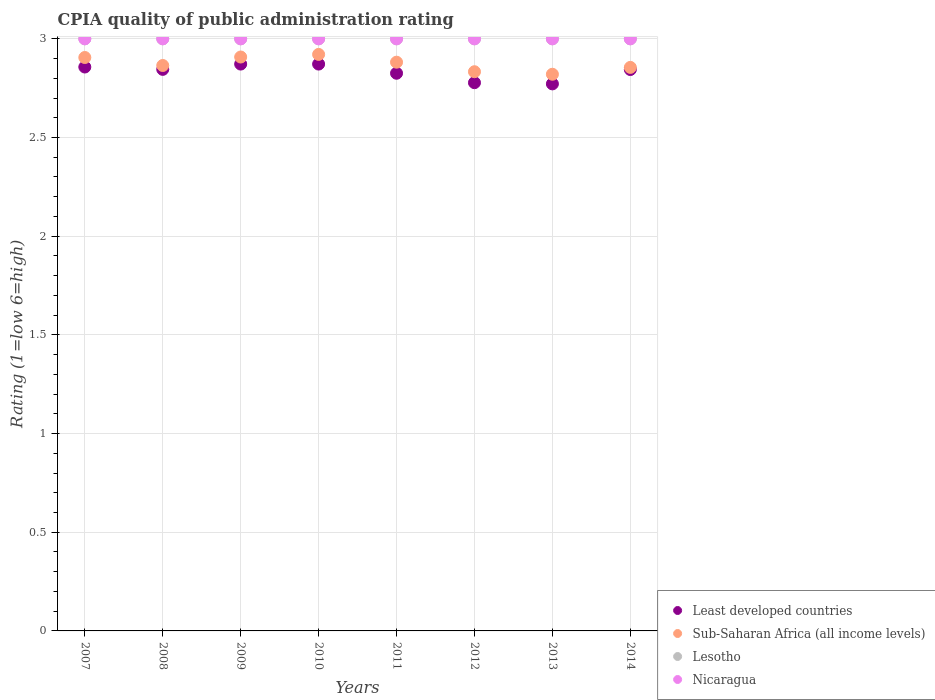Is the number of dotlines equal to the number of legend labels?
Keep it short and to the point. Yes. What is the CPIA rating in Sub-Saharan Africa (all income levels) in 2009?
Keep it short and to the point. 2.91. Across all years, what is the maximum CPIA rating in Nicaragua?
Provide a succinct answer. 3. Across all years, what is the minimum CPIA rating in Lesotho?
Make the answer very short. 3. In which year was the CPIA rating in Lesotho maximum?
Ensure brevity in your answer.  2007. In which year was the CPIA rating in Sub-Saharan Africa (all income levels) minimum?
Provide a short and direct response. 2013. What is the total CPIA rating in Lesotho in the graph?
Your answer should be very brief. 24. What is the difference between the CPIA rating in Sub-Saharan Africa (all income levels) in 2013 and the CPIA rating in Lesotho in 2008?
Give a very brief answer. -0.18. What is the average CPIA rating in Sub-Saharan Africa (all income levels) per year?
Provide a succinct answer. 2.87. In the year 2012, what is the difference between the CPIA rating in Sub-Saharan Africa (all income levels) and CPIA rating in Lesotho?
Offer a terse response. -0.17. In how many years, is the CPIA rating in Least developed countries greater than 1.4?
Make the answer very short. 8. What is the difference between the highest and the second highest CPIA rating in Lesotho?
Offer a terse response. 0. Is the sum of the CPIA rating in Sub-Saharan Africa (all income levels) in 2007 and 2012 greater than the maximum CPIA rating in Least developed countries across all years?
Offer a terse response. Yes. Is it the case that in every year, the sum of the CPIA rating in Lesotho and CPIA rating in Nicaragua  is greater than the sum of CPIA rating in Least developed countries and CPIA rating in Sub-Saharan Africa (all income levels)?
Keep it short and to the point. No. Is the CPIA rating in Nicaragua strictly greater than the CPIA rating in Lesotho over the years?
Your response must be concise. No. Is the CPIA rating in Sub-Saharan Africa (all income levels) strictly less than the CPIA rating in Nicaragua over the years?
Make the answer very short. Yes. How many dotlines are there?
Make the answer very short. 4. How many years are there in the graph?
Your answer should be very brief. 8. Does the graph contain any zero values?
Provide a succinct answer. No. Does the graph contain grids?
Keep it short and to the point. Yes. Where does the legend appear in the graph?
Your answer should be very brief. Bottom right. How many legend labels are there?
Provide a short and direct response. 4. How are the legend labels stacked?
Make the answer very short. Vertical. What is the title of the graph?
Keep it short and to the point. CPIA quality of public administration rating. What is the label or title of the X-axis?
Offer a very short reply. Years. What is the label or title of the Y-axis?
Give a very brief answer. Rating (1=low 6=high). What is the Rating (1=low 6=high) in Least developed countries in 2007?
Offer a very short reply. 2.86. What is the Rating (1=low 6=high) in Sub-Saharan Africa (all income levels) in 2007?
Offer a terse response. 2.91. What is the Rating (1=low 6=high) in Nicaragua in 2007?
Give a very brief answer. 3. What is the Rating (1=low 6=high) of Least developed countries in 2008?
Offer a very short reply. 2.85. What is the Rating (1=low 6=high) in Sub-Saharan Africa (all income levels) in 2008?
Ensure brevity in your answer.  2.86. What is the Rating (1=low 6=high) in Least developed countries in 2009?
Your response must be concise. 2.87. What is the Rating (1=low 6=high) of Sub-Saharan Africa (all income levels) in 2009?
Offer a terse response. 2.91. What is the Rating (1=low 6=high) in Lesotho in 2009?
Give a very brief answer. 3. What is the Rating (1=low 6=high) in Least developed countries in 2010?
Make the answer very short. 2.87. What is the Rating (1=low 6=high) in Sub-Saharan Africa (all income levels) in 2010?
Provide a short and direct response. 2.92. What is the Rating (1=low 6=high) in Lesotho in 2010?
Provide a succinct answer. 3. What is the Rating (1=low 6=high) of Nicaragua in 2010?
Make the answer very short. 3. What is the Rating (1=low 6=high) in Least developed countries in 2011?
Make the answer very short. 2.83. What is the Rating (1=low 6=high) of Sub-Saharan Africa (all income levels) in 2011?
Your response must be concise. 2.88. What is the Rating (1=low 6=high) of Least developed countries in 2012?
Your response must be concise. 2.78. What is the Rating (1=low 6=high) of Sub-Saharan Africa (all income levels) in 2012?
Your response must be concise. 2.83. What is the Rating (1=low 6=high) of Lesotho in 2012?
Give a very brief answer. 3. What is the Rating (1=low 6=high) in Nicaragua in 2012?
Give a very brief answer. 3. What is the Rating (1=low 6=high) of Least developed countries in 2013?
Provide a short and direct response. 2.77. What is the Rating (1=low 6=high) in Sub-Saharan Africa (all income levels) in 2013?
Keep it short and to the point. 2.82. What is the Rating (1=low 6=high) in Nicaragua in 2013?
Your answer should be very brief. 3. What is the Rating (1=low 6=high) in Least developed countries in 2014?
Provide a succinct answer. 2.84. What is the Rating (1=low 6=high) in Sub-Saharan Africa (all income levels) in 2014?
Your response must be concise. 2.86. What is the Rating (1=low 6=high) in Lesotho in 2014?
Your answer should be very brief. 3. Across all years, what is the maximum Rating (1=low 6=high) in Least developed countries?
Provide a short and direct response. 2.87. Across all years, what is the maximum Rating (1=low 6=high) of Sub-Saharan Africa (all income levels)?
Your answer should be compact. 2.92. Across all years, what is the maximum Rating (1=low 6=high) in Lesotho?
Keep it short and to the point. 3. Across all years, what is the minimum Rating (1=low 6=high) of Least developed countries?
Keep it short and to the point. 2.77. Across all years, what is the minimum Rating (1=low 6=high) of Sub-Saharan Africa (all income levels)?
Your answer should be compact. 2.82. Across all years, what is the minimum Rating (1=low 6=high) of Lesotho?
Offer a terse response. 3. What is the total Rating (1=low 6=high) in Least developed countries in the graph?
Give a very brief answer. 22.67. What is the total Rating (1=low 6=high) in Sub-Saharan Africa (all income levels) in the graph?
Provide a short and direct response. 22.99. What is the total Rating (1=low 6=high) of Lesotho in the graph?
Make the answer very short. 24. What is the difference between the Rating (1=low 6=high) of Least developed countries in 2007 and that in 2008?
Make the answer very short. 0.01. What is the difference between the Rating (1=low 6=high) of Sub-Saharan Africa (all income levels) in 2007 and that in 2008?
Your response must be concise. 0.04. What is the difference between the Rating (1=low 6=high) in Nicaragua in 2007 and that in 2008?
Offer a very short reply. 0. What is the difference between the Rating (1=low 6=high) of Least developed countries in 2007 and that in 2009?
Offer a very short reply. -0.01. What is the difference between the Rating (1=low 6=high) in Sub-Saharan Africa (all income levels) in 2007 and that in 2009?
Your answer should be very brief. -0. What is the difference between the Rating (1=low 6=high) in Nicaragua in 2007 and that in 2009?
Your answer should be very brief. 0. What is the difference between the Rating (1=low 6=high) in Least developed countries in 2007 and that in 2010?
Offer a very short reply. -0.01. What is the difference between the Rating (1=low 6=high) in Sub-Saharan Africa (all income levels) in 2007 and that in 2010?
Ensure brevity in your answer.  -0.02. What is the difference between the Rating (1=low 6=high) of Least developed countries in 2007 and that in 2011?
Offer a very short reply. 0.03. What is the difference between the Rating (1=low 6=high) in Sub-Saharan Africa (all income levels) in 2007 and that in 2011?
Your answer should be compact. 0.02. What is the difference between the Rating (1=low 6=high) of Nicaragua in 2007 and that in 2011?
Provide a succinct answer. 0. What is the difference between the Rating (1=low 6=high) of Least developed countries in 2007 and that in 2012?
Keep it short and to the point. 0.08. What is the difference between the Rating (1=low 6=high) in Sub-Saharan Africa (all income levels) in 2007 and that in 2012?
Make the answer very short. 0.07. What is the difference between the Rating (1=low 6=high) of Lesotho in 2007 and that in 2012?
Offer a very short reply. 0. What is the difference between the Rating (1=low 6=high) of Nicaragua in 2007 and that in 2012?
Your answer should be very brief. 0. What is the difference between the Rating (1=low 6=high) in Least developed countries in 2007 and that in 2013?
Ensure brevity in your answer.  0.09. What is the difference between the Rating (1=low 6=high) in Sub-Saharan Africa (all income levels) in 2007 and that in 2013?
Offer a terse response. 0.08. What is the difference between the Rating (1=low 6=high) of Lesotho in 2007 and that in 2013?
Provide a short and direct response. 0. What is the difference between the Rating (1=low 6=high) of Nicaragua in 2007 and that in 2013?
Offer a terse response. 0. What is the difference between the Rating (1=low 6=high) of Least developed countries in 2007 and that in 2014?
Offer a terse response. 0.01. What is the difference between the Rating (1=low 6=high) in Sub-Saharan Africa (all income levels) in 2007 and that in 2014?
Your response must be concise. 0.05. What is the difference between the Rating (1=low 6=high) of Nicaragua in 2007 and that in 2014?
Provide a succinct answer. 0. What is the difference between the Rating (1=low 6=high) in Least developed countries in 2008 and that in 2009?
Your response must be concise. -0.03. What is the difference between the Rating (1=low 6=high) of Sub-Saharan Africa (all income levels) in 2008 and that in 2009?
Give a very brief answer. -0.04. What is the difference between the Rating (1=low 6=high) in Least developed countries in 2008 and that in 2010?
Make the answer very short. -0.03. What is the difference between the Rating (1=low 6=high) of Sub-Saharan Africa (all income levels) in 2008 and that in 2010?
Keep it short and to the point. -0.06. What is the difference between the Rating (1=low 6=high) of Lesotho in 2008 and that in 2010?
Make the answer very short. 0. What is the difference between the Rating (1=low 6=high) of Nicaragua in 2008 and that in 2010?
Make the answer very short. 0. What is the difference between the Rating (1=low 6=high) in Least developed countries in 2008 and that in 2011?
Provide a short and direct response. 0.02. What is the difference between the Rating (1=low 6=high) in Sub-Saharan Africa (all income levels) in 2008 and that in 2011?
Provide a short and direct response. -0.02. What is the difference between the Rating (1=low 6=high) of Nicaragua in 2008 and that in 2011?
Offer a very short reply. 0. What is the difference between the Rating (1=low 6=high) of Least developed countries in 2008 and that in 2012?
Your answer should be compact. 0.07. What is the difference between the Rating (1=low 6=high) in Sub-Saharan Africa (all income levels) in 2008 and that in 2012?
Your answer should be very brief. 0.03. What is the difference between the Rating (1=low 6=high) of Lesotho in 2008 and that in 2012?
Provide a succinct answer. 0. What is the difference between the Rating (1=low 6=high) in Nicaragua in 2008 and that in 2012?
Provide a short and direct response. 0. What is the difference between the Rating (1=low 6=high) in Least developed countries in 2008 and that in 2013?
Your response must be concise. 0.07. What is the difference between the Rating (1=low 6=high) of Sub-Saharan Africa (all income levels) in 2008 and that in 2013?
Give a very brief answer. 0.04. What is the difference between the Rating (1=low 6=high) of Nicaragua in 2008 and that in 2013?
Your answer should be compact. 0. What is the difference between the Rating (1=low 6=high) of Least developed countries in 2008 and that in 2014?
Your answer should be very brief. 0. What is the difference between the Rating (1=low 6=high) in Sub-Saharan Africa (all income levels) in 2008 and that in 2014?
Offer a terse response. 0.01. What is the difference between the Rating (1=low 6=high) of Least developed countries in 2009 and that in 2010?
Offer a very short reply. 0. What is the difference between the Rating (1=low 6=high) of Sub-Saharan Africa (all income levels) in 2009 and that in 2010?
Ensure brevity in your answer.  -0.01. What is the difference between the Rating (1=low 6=high) in Lesotho in 2009 and that in 2010?
Offer a very short reply. 0. What is the difference between the Rating (1=low 6=high) of Nicaragua in 2009 and that in 2010?
Offer a very short reply. 0. What is the difference between the Rating (1=low 6=high) of Least developed countries in 2009 and that in 2011?
Provide a short and direct response. 0.05. What is the difference between the Rating (1=low 6=high) in Sub-Saharan Africa (all income levels) in 2009 and that in 2011?
Provide a short and direct response. 0.03. What is the difference between the Rating (1=low 6=high) of Least developed countries in 2009 and that in 2012?
Offer a very short reply. 0.09. What is the difference between the Rating (1=low 6=high) of Sub-Saharan Africa (all income levels) in 2009 and that in 2012?
Provide a short and direct response. 0.07. What is the difference between the Rating (1=low 6=high) of Least developed countries in 2009 and that in 2013?
Your response must be concise. 0.1. What is the difference between the Rating (1=low 6=high) of Sub-Saharan Africa (all income levels) in 2009 and that in 2013?
Provide a short and direct response. 0.09. What is the difference between the Rating (1=low 6=high) in Nicaragua in 2009 and that in 2013?
Offer a very short reply. 0. What is the difference between the Rating (1=low 6=high) of Least developed countries in 2009 and that in 2014?
Your answer should be very brief. 0.03. What is the difference between the Rating (1=low 6=high) of Sub-Saharan Africa (all income levels) in 2009 and that in 2014?
Ensure brevity in your answer.  0.05. What is the difference between the Rating (1=low 6=high) of Lesotho in 2009 and that in 2014?
Provide a short and direct response. 0. What is the difference between the Rating (1=low 6=high) of Nicaragua in 2009 and that in 2014?
Make the answer very short. 0. What is the difference between the Rating (1=low 6=high) of Least developed countries in 2010 and that in 2011?
Your answer should be compact. 0.05. What is the difference between the Rating (1=low 6=high) in Sub-Saharan Africa (all income levels) in 2010 and that in 2011?
Give a very brief answer. 0.04. What is the difference between the Rating (1=low 6=high) in Lesotho in 2010 and that in 2011?
Give a very brief answer. 0. What is the difference between the Rating (1=low 6=high) of Nicaragua in 2010 and that in 2011?
Offer a very short reply. 0. What is the difference between the Rating (1=low 6=high) in Least developed countries in 2010 and that in 2012?
Your response must be concise. 0.09. What is the difference between the Rating (1=low 6=high) of Sub-Saharan Africa (all income levels) in 2010 and that in 2012?
Give a very brief answer. 0.09. What is the difference between the Rating (1=low 6=high) in Nicaragua in 2010 and that in 2012?
Your answer should be very brief. 0. What is the difference between the Rating (1=low 6=high) in Least developed countries in 2010 and that in 2013?
Your answer should be compact. 0.1. What is the difference between the Rating (1=low 6=high) in Sub-Saharan Africa (all income levels) in 2010 and that in 2013?
Your answer should be compact. 0.1. What is the difference between the Rating (1=low 6=high) in Least developed countries in 2010 and that in 2014?
Give a very brief answer. 0.03. What is the difference between the Rating (1=low 6=high) in Sub-Saharan Africa (all income levels) in 2010 and that in 2014?
Ensure brevity in your answer.  0.07. What is the difference between the Rating (1=low 6=high) of Nicaragua in 2010 and that in 2014?
Offer a very short reply. 0. What is the difference between the Rating (1=low 6=high) of Least developed countries in 2011 and that in 2012?
Your answer should be compact. 0.05. What is the difference between the Rating (1=low 6=high) of Sub-Saharan Africa (all income levels) in 2011 and that in 2012?
Offer a terse response. 0.05. What is the difference between the Rating (1=low 6=high) in Nicaragua in 2011 and that in 2012?
Your answer should be compact. 0. What is the difference between the Rating (1=low 6=high) in Least developed countries in 2011 and that in 2013?
Provide a succinct answer. 0.05. What is the difference between the Rating (1=low 6=high) of Sub-Saharan Africa (all income levels) in 2011 and that in 2013?
Make the answer very short. 0.06. What is the difference between the Rating (1=low 6=high) in Nicaragua in 2011 and that in 2013?
Keep it short and to the point. 0. What is the difference between the Rating (1=low 6=high) of Least developed countries in 2011 and that in 2014?
Keep it short and to the point. -0.02. What is the difference between the Rating (1=low 6=high) of Sub-Saharan Africa (all income levels) in 2011 and that in 2014?
Keep it short and to the point. 0.03. What is the difference between the Rating (1=low 6=high) of Lesotho in 2011 and that in 2014?
Offer a very short reply. 0. What is the difference between the Rating (1=low 6=high) in Nicaragua in 2011 and that in 2014?
Your answer should be very brief. 0. What is the difference between the Rating (1=low 6=high) in Least developed countries in 2012 and that in 2013?
Ensure brevity in your answer.  0.01. What is the difference between the Rating (1=low 6=high) in Sub-Saharan Africa (all income levels) in 2012 and that in 2013?
Keep it short and to the point. 0.01. What is the difference between the Rating (1=low 6=high) in Lesotho in 2012 and that in 2013?
Offer a terse response. 0. What is the difference between the Rating (1=low 6=high) in Least developed countries in 2012 and that in 2014?
Your answer should be compact. -0.07. What is the difference between the Rating (1=low 6=high) of Sub-Saharan Africa (all income levels) in 2012 and that in 2014?
Your answer should be compact. -0.02. What is the difference between the Rating (1=low 6=high) of Lesotho in 2012 and that in 2014?
Your answer should be very brief. 0. What is the difference between the Rating (1=low 6=high) in Least developed countries in 2013 and that in 2014?
Your answer should be very brief. -0.07. What is the difference between the Rating (1=low 6=high) of Sub-Saharan Africa (all income levels) in 2013 and that in 2014?
Give a very brief answer. -0.03. What is the difference between the Rating (1=low 6=high) of Nicaragua in 2013 and that in 2014?
Your answer should be compact. 0. What is the difference between the Rating (1=low 6=high) of Least developed countries in 2007 and the Rating (1=low 6=high) of Sub-Saharan Africa (all income levels) in 2008?
Offer a terse response. -0.01. What is the difference between the Rating (1=low 6=high) in Least developed countries in 2007 and the Rating (1=low 6=high) in Lesotho in 2008?
Make the answer very short. -0.14. What is the difference between the Rating (1=low 6=high) of Least developed countries in 2007 and the Rating (1=low 6=high) of Nicaragua in 2008?
Keep it short and to the point. -0.14. What is the difference between the Rating (1=low 6=high) in Sub-Saharan Africa (all income levels) in 2007 and the Rating (1=low 6=high) in Lesotho in 2008?
Provide a succinct answer. -0.09. What is the difference between the Rating (1=low 6=high) of Sub-Saharan Africa (all income levels) in 2007 and the Rating (1=low 6=high) of Nicaragua in 2008?
Your answer should be very brief. -0.09. What is the difference between the Rating (1=low 6=high) in Least developed countries in 2007 and the Rating (1=low 6=high) in Sub-Saharan Africa (all income levels) in 2009?
Ensure brevity in your answer.  -0.05. What is the difference between the Rating (1=low 6=high) of Least developed countries in 2007 and the Rating (1=low 6=high) of Lesotho in 2009?
Give a very brief answer. -0.14. What is the difference between the Rating (1=low 6=high) in Least developed countries in 2007 and the Rating (1=low 6=high) in Nicaragua in 2009?
Offer a very short reply. -0.14. What is the difference between the Rating (1=low 6=high) in Sub-Saharan Africa (all income levels) in 2007 and the Rating (1=low 6=high) in Lesotho in 2009?
Your response must be concise. -0.09. What is the difference between the Rating (1=low 6=high) of Sub-Saharan Africa (all income levels) in 2007 and the Rating (1=low 6=high) of Nicaragua in 2009?
Provide a short and direct response. -0.09. What is the difference between the Rating (1=low 6=high) of Lesotho in 2007 and the Rating (1=low 6=high) of Nicaragua in 2009?
Offer a very short reply. 0. What is the difference between the Rating (1=low 6=high) in Least developed countries in 2007 and the Rating (1=low 6=high) in Sub-Saharan Africa (all income levels) in 2010?
Offer a very short reply. -0.06. What is the difference between the Rating (1=low 6=high) of Least developed countries in 2007 and the Rating (1=low 6=high) of Lesotho in 2010?
Keep it short and to the point. -0.14. What is the difference between the Rating (1=low 6=high) of Least developed countries in 2007 and the Rating (1=low 6=high) of Nicaragua in 2010?
Make the answer very short. -0.14. What is the difference between the Rating (1=low 6=high) in Sub-Saharan Africa (all income levels) in 2007 and the Rating (1=low 6=high) in Lesotho in 2010?
Make the answer very short. -0.09. What is the difference between the Rating (1=low 6=high) of Sub-Saharan Africa (all income levels) in 2007 and the Rating (1=low 6=high) of Nicaragua in 2010?
Keep it short and to the point. -0.09. What is the difference between the Rating (1=low 6=high) of Least developed countries in 2007 and the Rating (1=low 6=high) of Sub-Saharan Africa (all income levels) in 2011?
Offer a very short reply. -0.02. What is the difference between the Rating (1=low 6=high) in Least developed countries in 2007 and the Rating (1=low 6=high) in Lesotho in 2011?
Provide a short and direct response. -0.14. What is the difference between the Rating (1=low 6=high) in Least developed countries in 2007 and the Rating (1=low 6=high) in Nicaragua in 2011?
Your response must be concise. -0.14. What is the difference between the Rating (1=low 6=high) in Sub-Saharan Africa (all income levels) in 2007 and the Rating (1=low 6=high) in Lesotho in 2011?
Make the answer very short. -0.09. What is the difference between the Rating (1=low 6=high) in Sub-Saharan Africa (all income levels) in 2007 and the Rating (1=low 6=high) in Nicaragua in 2011?
Your response must be concise. -0.09. What is the difference between the Rating (1=low 6=high) of Lesotho in 2007 and the Rating (1=low 6=high) of Nicaragua in 2011?
Keep it short and to the point. 0. What is the difference between the Rating (1=low 6=high) of Least developed countries in 2007 and the Rating (1=low 6=high) of Sub-Saharan Africa (all income levels) in 2012?
Your answer should be compact. 0.02. What is the difference between the Rating (1=low 6=high) in Least developed countries in 2007 and the Rating (1=low 6=high) in Lesotho in 2012?
Give a very brief answer. -0.14. What is the difference between the Rating (1=low 6=high) of Least developed countries in 2007 and the Rating (1=low 6=high) of Nicaragua in 2012?
Give a very brief answer. -0.14. What is the difference between the Rating (1=low 6=high) of Sub-Saharan Africa (all income levels) in 2007 and the Rating (1=low 6=high) of Lesotho in 2012?
Offer a terse response. -0.09. What is the difference between the Rating (1=low 6=high) of Sub-Saharan Africa (all income levels) in 2007 and the Rating (1=low 6=high) of Nicaragua in 2012?
Make the answer very short. -0.09. What is the difference between the Rating (1=low 6=high) in Lesotho in 2007 and the Rating (1=low 6=high) in Nicaragua in 2012?
Provide a short and direct response. 0. What is the difference between the Rating (1=low 6=high) of Least developed countries in 2007 and the Rating (1=low 6=high) of Sub-Saharan Africa (all income levels) in 2013?
Make the answer very short. 0.04. What is the difference between the Rating (1=low 6=high) in Least developed countries in 2007 and the Rating (1=low 6=high) in Lesotho in 2013?
Your answer should be compact. -0.14. What is the difference between the Rating (1=low 6=high) in Least developed countries in 2007 and the Rating (1=low 6=high) in Nicaragua in 2013?
Ensure brevity in your answer.  -0.14. What is the difference between the Rating (1=low 6=high) in Sub-Saharan Africa (all income levels) in 2007 and the Rating (1=low 6=high) in Lesotho in 2013?
Provide a succinct answer. -0.09. What is the difference between the Rating (1=low 6=high) in Sub-Saharan Africa (all income levels) in 2007 and the Rating (1=low 6=high) in Nicaragua in 2013?
Offer a very short reply. -0.09. What is the difference between the Rating (1=low 6=high) of Lesotho in 2007 and the Rating (1=low 6=high) of Nicaragua in 2013?
Ensure brevity in your answer.  0. What is the difference between the Rating (1=low 6=high) in Least developed countries in 2007 and the Rating (1=low 6=high) in Sub-Saharan Africa (all income levels) in 2014?
Offer a very short reply. 0. What is the difference between the Rating (1=low 6=high) in Least developed countries in 2007 and the Rating (1=low 6=high) in Lesotho in 2014?
Your response must be concise. -0.14. What is the difference between the Rating (1=low 6=high) of Least developed countries in 2007 and the Rating (1=low 6=high) of Nicaragua in 2014?
Offer a very short reply. -0.14. What is the difference between the Rating (1=low 6=high) in Sub-Saharan Africa (all income levels) in 2007 and the Rating (1=low 6=high) in Lesotho in 2014?
Your answer should be very brief. -0.09. What is the difference between the Rating (1=low 6=high) in Sub-Saharan Africa (all income levels) in 2007 and the Rating (1=low 6=high) in Nicaragua in 2014?
Provide a short and direct response. -0.09. What is the difference between the Rating (1=low 6=high) in Lesotho in 2007 and the Rating (1=low 6=high) in Nicaragua in 2014?
Provide a succinct answer. 0. What is the difference between the Rating (1=low 6=high) in Least developed countries in 2008 and the Rating (1=low 6=high) in Sub-Saharan Africa (all income levels) in 2009?
Make the answer very short. -0.06. What is the difference between the Rating (1=low 6=high) of Least developed countries in 2008 and the Rating (1=low 6=high) of Lesotho in 2009?
Offer a very short reply. -0.15. What is the difference between the Rating (1=low 6=high) of Least developed countries in 2008 and the Rating (1=low 6=high) of Nicaragua in 2009?
Make the answer very short. -0.15. What is the difference between the Rating (1=low 6=high) in Sub-Saharan Africa (all income levels) in 2008 and the Rating (1=low 6=high) in Lesotho in 2009?
Give a very brief answer. -0.14. What is the difference between the Rating (1=low 6=high) in Sub-Saharan Africa (all income levels) in 2008 and the Rating (1=low 6=high) in Nicaragua in 2009?
Provide a succinct answer. -0.14. What is the difference between the Rating (1=low 6=high) in Lesotho in 2008 and the Rating (1=low 6=high) in Nicaragua in 2009?
Make the answer very short. 0. What is the difference between the Rating (1=low 6=high) of Least developed countries in 2008 and the Rating (1=low 6=high) of Sub-Saharan Africa (all income levels) in 2010?
Provide a short and direct response. -0.08. What is the difference between the Rating (1=low 6=high) in Least developed countries in 2008 and the Rating (1=low 6=high) in Lesotho in 2010?
Keep it short and to the point. -0.15. What is the difference between the Rating (1=low 6=high) of Least developed countries in 2008 and the Rating (1=low 6=high) of Nicaragua in 2010?
Offer a terse response. -0.15. What is the difference between the Rating (1=low 6=high) in Sub-Saharan Africa (all income levels) in 2008 and the Rating (1=low 6=high) in Lesotho in 2010?
Offer a terse response. -0.14. What is the difference between the Rating (1=low 6=high) of Sub-Saharan Africa (all income levels) in 2008 and the Rating (1=low 6=high) of Nicaragua in 2010?
Make the answer very short. -0.14. What is the difference between the Rating (1=low 6=high) in Least developed countries in 2008 and the Rating (1=low 6=high) in Sub-Saharan Africa (all income levels) in 2011?
Your answer should be very brief. -0.04. What is the difference between the Rating (1=low 6=high) in Least developed countries in 2008 and the Rating (1=low 6=high) in Lesotho in 2011?
Make the answer very short. -0.15. What is the difference between the Rating (1=low 6=high) of Least developed countries in 2008 and the Rating (1=low 6=high) of Nicaragua in 2011?
Offer a terse response. -0.15. What is the difference between the Rating (1=low 6=high) in Sub-Saharan Africa (all income levels) in 2008 and the Rating (1=low 6=high) in Lesotho in 2011?
Offer a terse response. -0.14. What is the difference between the Rating (1=low 6=high) in Sub-Saharan Africa (all income levels) in 2008 and the Rating (1=low 6=high) in Nicaragua in 2011?
Your answer should be compact. -0.14. What is the difference between the Rating (1=low 6=high) of Lesotho in 2008 and the Rating (1=low 6=high) of Nicaragua in 2011?
Offer a terse response. 0. What is the difference between the Rating (1=low 6=high) in Least developed countries in 2008 and the Rating (1=low 6=high) in Sub-Saharan Africa (all income levels) in 2012?
Make the answer very short. 0.01. What is the difference between the Rating (1=low 6=high) in Least developed countries in 2008 and the Rating (1=low 6=high) in Lesotho in 2012?
Your answer should be compact. -0.15. What is the difference between the Rating (1=low 6=high) of Least developed countries in 2008 and the Rating (1=low 6=high) of Nicaragua in 2012?
Your response must be concise. -0.15. What is the difference between the Rating (1=low 6=high) in Sub-Saharan Africa (all income levels) in 2008 and the Rating (1=low 6=high) in Lesotho in 2012?
Provide a succinct answer. -0.14. What is the difference between the Rating (1=low 6=high) in Sub-Saharan Africa (all income levels) in 2008 and the Rating (1=low 6=high) in Nicaragua in 2012?
Provide a short and direct response. -0.14. What is the difference between the Rating (1=low 6=high) of Least developed countries in 2008 and the Rating (1=low 6=high) of Sub-Saharan Africa (all income levels) in 2013?
Your answer should be very brief. 0.02. What is the difference between the Rating (1=low 6=high) in Least developed countries in 2008 and the Rating (1=low 6=high) in Lesotho in 2013?
Your response must be concise. -0.15. What is the difference between the Rating (1=low 6=high) of Least developed countries in 2008 and the Rating (1=low 6=high) of Nicaragua in 2013?
Give a very brief answer. -0.15. What is the difference between the Rating (1=low 6=high) in Sub-Saharan Africa (all income levels) in 2008 and the Rating (1=low 6=high) in Lesotho in 2013?
Your answer should be compact. -0.14. What is the difference between the Rating (1=low 6=high) of Sub-Saharan Africa (all income levels) in 2008 and the Rating (1=low 6=high) of Nicaragua in 2013?
Ensure brevity in your answer.  -0.14. What is the difference between the Rating (1=low 6=high) of Lesotho in 2008 and the Rating (1=low 6=high) of Nicaragua in 2013?
Your answer should be very brief. 0. What is the difference between the Rating (1=low 6=high) in Least developed countries in 2008 and the Rating (1=low 6=high) in Sub-Saharan Africa (all income levels) in 2014?
Keep it short and to the point. -0.01. What is the difference between the Rating (1=low 6=high) of Least developed countries in 2008 and the Rating (1=low 6=high) of Lesotho in 2014?
Keep it short and to the point. -0.15. What is the difference between the Rating (1=low 6=high) in Least developed countries in 2008 and the Rating (1=low 6=high) in Nicaragua in 2014?
Provide a succinct answer. -0.15. What is the difference between the Rating (1=low 6=high) of Sub-Saharan Africa (all income levels) in 2008 and the Rating (1=low 6=high) of Lesotho in 2014?
Offer a very short reply. -0.14. What is the difference between the Rating (1=low 6=high) in Sub-Saharan Africa (all income levels) in 2008 and the Rating (1=low 6=high) in Nicaragua in 2014?
Your answer should be very brief. -0.14. What is the difference between the Rating (1=low 6=high) of Lesotho in 2008 and the Rating (1=low 6=high) of Nicaragua in 2014?
Provide a short and direct response. 0. What is the difference between the Rating (1=low 6=high) in Least developed countries in 2009 and the Rating (1=low 6=high) in Sub-Saharan Africa (all income levels) in 2010?
Offer a very short reply. -0.05. What is the difference between the Rating (1=low 6=high) of Least developed countries in 2009 and the Rating (1=low 6=high) of Lesotho in 2010?
Give a very brief answer. -0.13. What is the difference between the Rating (1=low 6=high) of Least developed countries in 2009 and the Rating (1=low 6=high) of Nicaragua in 2010?
Provide a succinct answer. -0.13. What is the difference between the Rating (1=low 6=high) of Sub-Saharan Africa (all income levels) in 2009 and the Rating (1=low 6=high) of Lesotho in 2010?
Ensure brevity in your answer.  -0.09. What is the difference between the Rating (1=low 6=high) of Sub-Saharan Africa (all income levels) in 2009 and the Rating (1=low 6=high) of Nicaragua in 2010?
Your answer should be compact. -0.09. What is the difference between the Rating (1=low 6=high) of Lesotho in 2009 and the Rating (1=low 6=high) of Nicaragua in 2010?
Your answer should be compact. 0. What is the difference between the Rating (1=low 6=high) in Least developed countries in 2009 and the Rating (1=low 6=high) in Sub-Saharan Africa (all income levels) in 2011?
Offer a very short reply. -0.01. What is the difference between the Rating (1=low 6=high) in Least developed countries in 2009 and the Rating (1=low 6=high) in Lesotho in 2011?
Provide a succinct answer. -0.13. What is the difference between the Rating (1=low 6=high) in Least developed countries in 2009 and the Rating (1=low 6=high) in Nicaragua in 2011?
Make the answer very short. -0.13. What is the difference between the Rating (1=low 6=high) of Sub-Saharan Africa (all income levels) in 2009 and the Rating (1=low 6=high) of Lesotho in 2011?
Your response must be concise. -0.09. What is the difference between the Rating (1=low 6=high) in Sub-Saharan Africa (all income levels) in 2009 and the Rating (1=low 6=high) in Nicaragua in 2011?
Offer a very short reply. -0.09. What is the difference between the Rating (1=low 6=high) of Least developed countries in 2009 and the Rating (1=low 6=high) of Sub-Saharan Africa (all income levels) in 2012?
Ensure brevity in your answer.  0.04. What is the difference between the Rating (1=low 6=high) in Least developed countries in 2009 and the Rating (1=low 6=high) in Lesotho in 2012?
Your answer should be very brief. -0.13. What is the difference between the Rating (1=low 6=high) in Least developed countries in 2009 and the Rating (1=low 6=high) in Nicaragua in 2012?
Your response must be concise. -0.13. What is the difference between the Rating (1=low 6=high) of Sub-Saharan Africa (all income levels) in 2009 and the Rating (1=low 6=high) of Lesotho in 2012?
Make the answer very short. -0.09. What is the difference between the Rating (1=low 6=high) in Sub-Saharan Africa (all income levels) in 2009 and the Rating (1=low 6=high) in Nicaragua in 2012?
Make the answer very short. -0.09. What is the difference between the Rating (1=low 6=high) of Least developed countries in 2009 and the Rating (1=low 6=high) of Sub-Saharan Africa (all income levels) in 2013?
Make the answer very short. 0.05. What is the difference between the Rating (1=low 6=high) in Least developed countries in 2009 and the Rating (1=low 6=high) in Lesotho in 2013?
Ensure brevity in your answer.  -0.13. What is the difference between the Rating (1=low 6=high) of Least developed countries in 2009 and the Rating (1=low 6=high) of Nicaragua in 2013?
Your answer should be very brief. -0.13. What is the difference between the Rating (1=low 6=high) in Sub-Saharan Africa (all income levels) in 2009 and the Rating (1=low 6=high) in Lesotho in 2013?
Provide a short and direct response. -0.09. What is the difference between the Rating (1=low 6=high) in Sub-Saharan Africa (all income levels) in 2009 and the Rating (1=low 6=high) in Nicaragua in 2013?
Offer a terse response. -0.09. What is the difference between the Rating (1=low 6=high) in Lesotho in 2009 and the Rating (1=low 6=high) in Nicaragua in 2013?
Provide a succinct answer. 0. What is the difference between the Rating (1=low 6=high) in Least developed countries in 2009 and the Rating (1=low 6=high) in Sub-Saharan Africa (all income levels) in 2014?
Ensure brevity in your answer.  0.02. What is the difference between the Rating (1=low 6=high) in Least developed countries in 2009 and the Rating (1=low 6=high) in Lesotho in 2014?
Provide a short and direct response. -0.13. What is the difference between the Rating (1=low 6=high) in Least developed countries in 2009 and the Rating (1=low 6=high) in Nicaragua in 2014?
Your answer should be compact. -0.13. What is the difference between the Rating (1=low 6=high) in Sub-Saharan Africa (all income levels) in 2009 and the Rating (1=low 6=high) in Lesotho in 2014?
Your answer should be compact. -0.09. What is the difference between the Rating (1=low 6=high) of Sub-Saharan Africa (all income levels) in 2009 and the Rating (1=low 6=high) of Nicaragua in 2014?
Provide a succinct answer. -0.09. What is the difference between the Rating (1=low 6=high) in Least developed countries in 2010 and the Rating (1=low 6=high) in Sub-Saharan Africa (all income levels) in 2011?
Provide a succinct answer. -0.01. What is the difference between the Rating (1=low 6=high) in Least developed countries in 2010 and the Rating (1=low 6=high) in Lesotho in 2011?
Keep it short and to the point. -0.13. What is the difference between the Rating (1=low 6=high) in Least developed countries in 2010 and the Rating (1=low 6=high) in Nicaragua in 2011?
Give a very brief answer. -0.13. What is the difference between the Rating (1=low 6=high) in Sub-Saharan Africa (all income levels) in 2010 and the Rating (1=low 6=high) in Lesotho in 2011?
Ensure brevity in your answer.  -0.08. What is the difference between the Rating (1=low 6=high) of Sub-Saharan Africa (all income levels) in 2010 and the Rating (1=low 6=high) of Nicaragua in 2011?
Your response must be concise. -0.08. What is the difference between the Rating (1=low 6=high) in Least developed countries in 2010 and the Rating (1=low 6=high) in Sub-Saharan Africa (all income levels) in 2012?
Your answer should be very brief. 0.04. What is the difference between the Rating (1=low 6=high) in Least developed countries in 2010 and the Rating (1=low 6=high) in Lesotho in 2012?
Keep it short and to the point. -0.13. What is the difference between the Rating (1=low 6=high) of Least developed countries in 2010 and the Rating (1=low 6=high) of Nicaragua in 2012?
Give a very brief answer. -0.13. What is the difference between the Rating (1=low 6=high) in Sub-Saharan Africa (all income levels) in 2010 and the Rating (1=low 6=high) in Lesotho in 2012?
Your answer should be very brief. -0.08. What is the difference between the Rating (1=low 6=high) of Sub-Saharan Africa (all income levels) in 2010 and the Rating (1=low 6=high) of Nicaragua in 2012?
Offer a very short reply. -0.08. What is the difference between the Rating (1=low 6=high) in Lesotho in 2010 and the Rating (1=low 6=high) in Nicaragua in 2012?
Your answer should be compact. 0. What is the difference between the Rating (1=low 6=high) of Least developed countries in 2010 and the Rating (1=low 6=high) of Sub-Saharan Africa (all income levels) in 2013?
Give a very brief answer. 0.05. What is the difference between the Rating (1=low 6=high) in Least developed countries in 2010 and the Rating (1=low 6=high) in Lesotho in 2013?
Keep it short and to the point. -0.13. What is the difference between the Rating (1=low 6=high) in Least developed countries in 2010 and the Rating (1=low 6=high) in Nicaragua in 2013?
Offer a terse response. -0.13. What is the difference between the Rating (1=low 6=high) in Sub-Saharan Africa (all income levels) in 2010 and the Rating (1=low 6=high) in Lesotho in 2013?
Your answer should be compact. -0.08. What is the difference between the Rating (1=low 6=high) of Sub-Saharan Africa (all income levels) in 2010 and the Rating (1=low 6=high) of Nicaragua in 2013?
Offer a terse response. -0.08. What is the difference between the Rating (1=low 6=high) in Lesotho in 2010 and the Rating (1=low 6=high) in Nicaragua in 2013?
Your answer should be very brief. 0. What is the difference between the Rating (1=low 6=high) in Least developed countries in 2010 and the Rating (1=low 6=high) in Sub-Saharan Africa (all income levels) in 2014?
Your response must be concise. 0.02. What is the difference between the Rating (1=low 6=high) in Least developed countries in 2010 and the Rating (1=low 6=high) in Lesotho in 2014?
Provide a short and direct response. -0.13. What is the difference between the Rating (1=low 6=high) in Least developed countries in 2010 and the Rating (1=low 6=high) in Nicaragua in 2014?
Offer a very short reply. -0.13. What is the difference between the Rating (1=low 6=high) in Sub-Saharan Africa (all income levels) in 2010 and the Rating (1=low 6=high) in Lesotho in 2014?
Provide a succinct answer. -0.08. What is the difference between the Rating (1=low 6=high) in Sub-Saharan Africa (all income levels) in 2010 and the Rating (1=low 6=high) in Nicaragua in 2014?
Offer a very short reply. -0.08. What is the difference between the Rating (1=low 6=high) of Least developed countries in 2011 and the Rating (1=low 6=high) of Sub-Saharan Africa (all income levels) in 2012?
Your response must be concise. -0.01. What is the difference between the Rating (1=low 6=high) of Least developed countries in 2011 and the Rating (1=low 6=high) of Lesotho in 2012?
Your answer should be compact. -0.17. What is the difference between the Rating (1=low 6=high) in Least developed countries in 2011 and the Rating (1=low 6=high) in Nicaragua in 2012?
Keep it short and to the point. -0.17. What is the difference between the Rating (1=low 6=high) in Sub-Saharan Africa (all income levels) in 2011 and the Rating (1=low 6=high) in Lesotho in 2012?
Make the answer very short. -0.12. What is the difference between the Rating (1=low 6=high) in Sub-Saharan Africa (all income levels) in 2011 and the Rating (1=low 6=high) in Nicaragua in 2012?
Offer a terse response. -0.12. What is the difference between the Rating (1=low 6=high) of Lesotho in 2011 and the Rating (1=low 6=high) of Nicaragua in 2012?
Your response must be concise. 0. What is the difference between the Rating (1=low 6=high) in Least developed countries in 2011 and the Rating (1=low 6=high) in Sub-Saharan Africa (all income levels) in 2013?
Provide a succinct answer. 0.01. What is the difference between the Rating (1=low 6=high) in Least developed countries in 2011 and the Rating (1=low 6=high) in Lesotho in 2013?
Offer a very short reply. -0.17. What is the difference between the Rating (1=low 6=high) in Least developed countries in 2011 and the Rating (1=low 6=high) in Nicaragua in 2013?
Your answer should be compact. -0.17. What is the difference between the Rating (1=low 6=high) of Sub-Saharan Africa (all income levels) in 2011 and the Rating (1=low 6=high) of Lesotho in 2013?
Give a very brief answer. -0.12. What is the difference between the Rating (1=low 6=high) in Sub-Saharan Africa (all income levels) in 2011 and the Rating (1=low 6=high) in Nicaragua in 2013?
Make the answer very short. -0.12. What is the difference between the Rating (1=low 6=high) in Least developed countries in 2011 and the Rating (1=low 6=high) in Sub-Saharan Africa (all income levels) in 2014?
Provide a short and direct response. -0.03. What is the difference between the Rating (1=low 6=high) of Least developed countries in 2011 and the Rating (1=low 6=high) of Lesotho in 2014?
Your response must be concise. -0.17. What is the difference between the Rating (1=low 6=high) of Least developed countries in 2011 and the Rating (1=low 6=high) of Nicaragua in 2014?
Your answer should be compact. -0.17. What is the difference between the Rating (1=low 6=high) in Sub-Saharan Africa (all income levels) in 2011 and the Rating (1=low 6=high) in Lesotho in 2014?
Give a very brief answer. -0.12. What is the difference between the Rating (1=low 6=high) in Sub-Saharan Africa (all income levels) in 2011 and the Rating (1=low 6=high) in Nicaragua in 2014?
Your answer should be very brief. -0.12. What is the difference between the Rating (1=low 6=high) of Lesotho in 2011 and the Rating (1=low 6=high) of Nicaragua in 2014?
Make the answer very short. 0. What is the difference between the Rating (1=low 6=high) of Least developed countries in 2012 and the Rating (1=low 6=high) of Sub-Saharan Africa (all income levels) in 2013?
Keep it short and to the point. -0.04. What is the difference between the Rating (1=low 6=high) of Least developed countries in 2012 and the Rating (1=low 6=high) of Lesotho in 2013?
Keep it short and to the point. -0.22. What is the difference between the Rating (1=low 6=high) of Least developed countries in 2012 and the Rating (1=low 6=high) of Nicaragua in 2013?
Your answer should be very brief. -0.22. What is the difference between the Rating (1=low 6=high) of Sub-Saharan Africa (all income levels) in 2012 and the Rating (1=low 6=high) of Nicaragua in 2013?
Your response must be concise. -0.17. What is the difference between the Rating (1=low 6=high) in Least developed countries in 2012 and the Rating (1=low 6=high) in Sub-Saharan Africa (all income levels) in 2014?
Give a very brief answer. -0.08. What is the difference between the Rating (1=low 6=high) of Least developed countries in 2012 and the Rating (1=low 6=high) of Lesotho in 2014?
Make the answer very short. -0.22. What is the difference between the Rating (1=low 6=high) in Least developed countries in 2012 and the Rating (1=low 6=high) in Nicaragua in 2014?
Make the answer very short. -0.22. What is the difference between the Rating (1=low 6=high) of Sub-Saharan Africa (all income levels) in 2012 and the Rating (1=low 6=high) of Nicaragua in 2014?
Offer a very short reply. -0.17. What is the difference between the Rating (1=low 6=high) in Lesotho in 2012 and the Rating (1=low 6=high) in Nicaragua in 2014?
Make the answer very short. 0. What is the difference between the Rating (1=low 6=high) in Least developed countries in 2013 and the Rating (1=low 6=high) in Sub-Saharan Africa (all income levels) in 2014?
Your answer should be very brief. -0.08. What is the difference between the Rating (1=low 6=high) of Least developed countries in 2013 and the Rating (1=low 6=high) of Lesotho in 2014?
Your answer should be compact. -0.23. What is the difference between the Rating (1=low 6=high) of Least developed countries in 2013 and the Rating (1=low 6=high) of Nicaragua in 2014?
Provide a short and direct response. -0.23. What is the difference between the Rating (1=low 6=high) in Sub-Saharan Africa (all income levels) in 2013 and the Rating (1=low 6=high) in Lesotho in 2014?
Ensure brevity in your answer.  -0.18. What is the difference between the Rating (1=low 6=high) of Sub-Saharan Africa (all income levels) in 2013 and the Rating (1=low 6=high) of Nicaragua in 2014?
Make the answer very short. -0.18. What is the difference between the Rating (1=low 6=high) of Lesotho in 2013 and the Rating (1=low 6=high) of Nicaragua in 2014?
Ensure brevity in your answer.  0. What is the average Rating (1=low 6=high) of Least developed countries per year?
Offer a terse response. 2.83. What is the average Rating (1=low 6=high) of Sub-Saharan Africa (all income levels) per year?
Make the answer very short. 2.87. What is the average Rating (1=low 6=high) in Nicaragua per year?
Give a very brief answer. 3. In the year 2007, what is the difference between the Rating (1=low 6=high) in Least developed countries and Rating (1=low 6=high) in Sub-Saharan Africa (all income levels)?
Keep it short and to the point. -0.05. In the year 2007, what is the difference between the Rating (1=low 6=high) in Least developed countries and Rating (1=low 6=high) in Lesotho?
Your answer should be compact. -0.14. In the year 2007, what is the difference between the Rating (1=low 6=high) in Least developed countries and Rating (1=low 6=high) in Nicaragua?
Your response must be concise. -0.14. In the year 2007, what is the difference between the Rating (1=low 6=high) in Sub-Saharan Africa (all income levels) and Rating (1=low 6=high) in Lesotho?
Make the answer very short. -0.09. In the year 2007, what is the difference between the Rating (1=low 6=high) in Sub-Saharan Africa (all income levels) and Rating (1=low 6=high) in Nicaragua?
Provide a short and direct response. -0.09. In the year 2007, what is the difference between the Rating (1=low 6=high) of Lesotho and Rating (1=low 6=high) of Nicaragua?
Give a very brief answer. 0. In the year 2008, what is the difference between the Rating (1=low 6=high) of Least developed countries and Rating (1=low 6=high) of Sub-Saharan Africa (all income levels)?
Offer a terse response. -0.02. In the year 2008, what is the difference between the Rating (1=low 6=high) in Least developed countries and Rating (1=low 6=high) in Lesotho?
Keep it short and to the point. -0.15. In the year 2008, what is the difference between the Rating (1=low 6=high) of Least developed countries and Rating (1=low 6=high) of Nicaragua?
Give a very brief answer. -0.15. In the year 2008, what is the difference between the Rating (1=low 6=high) in Sub-Saharan Africa (all income levels) and Rating (1=low 6=high) in Lesotho?
Provide a succinct answer. -0.14. In the year 2008, what is the difference between the Rating (1=low 6=high) of Sub-Saharan Africa (all income levels) and Rating (1=low 6=high) of Nicaragua?
Ensure brevity in your answer.  -0.14. In the year 2008, what is the difference between the Rating (1=low 6=high) of Lesotho and Rating (1=low 6=high) of Nicaragua?
Keep it short and to the point. 0. In the year 2009, what is the difference between the Rating (1=low 6=high) of Least developed countries and Rating (1=low 6=high) of Sub-Saharan Africa (all income levels)?
Make the answer very short. -0.04. In the year 2009, what is the difference between the Rating (1=low 6=high) of Least developed countries and Rating (1=low 6=high) of Lesotho?
Offer a very short reply. -0.13. In the year 2009, what is the difference between the Rating (1=low 6=high) of Least developed countries and Rating (1=low 6=high) of Nicaragua?
Give a very brief answer. -0.13. In the year 2009, what is the difference between the Rating (1=low 6=high) of Sub-Saharan Africa (all income levels) and Rating (1=low 6=high) of Lesotho?
Make the answer very short. -0.09. In the year 2009, what is the difference between the Rating (1=low 6=high) of Sub-Saharan Africa (all income levels) and Rating (1=low 6=high) of Nicaragua?
Offer a terse response. -0.09. In the year 2009, what is the difference between the Rating (1=low 6=high) of Lesotho and Rating (1=low 6=high) of Nicaragua?
Your response must be concise. 0. In the year 2010, what is the difference between the Rating (1=low 6=high) in Least developed countries and Rating (1=low 6=high) in Sub-Saharan Africa (all income levels)?
Keep it short and to the point. -0.05. In the year 2010, what is the difference between the Rating (1=low 6=high) in Least developed countries and Rating (1=low 6=high) in Lesotho?
Provide a succinct answer. -0.13. In the year 2010, what is the difference between the Rating (1=low 6=high) in Least developed countries and Rating (1=low 6=high) in Nicaragua?
Offer a very short reply. -0.13. In the year 2010, what is the difference between the Rating (1=low 6=high) of Sub-Saharan Africa (all income levels) and Rating (1=low 6=high) of Lesotho?
Keep it short and to the point. -0.08. In the year 2010, what is the difference between the Rating (1=low 6=high) in Sub-Saharan Africa (all income levels) and Rating (1=low 6=high) in Nicaragua?
Provide a short and direct response. -0.08. In the year 2011, what is the difference between the Rating (1=low 6=high) of Least developed countries and Rating (1=low 6=high) of Sub-Saharan Africa (all income levels)?
Keep it short and to the point. -0.06. In the year 2011, what is the difference between the Rating (1=low 6=high) of Least developed countries and Rating (1=low 6=high) of Lesotho?
Keep it short and to the point. -0.17. In the year 2011, what is the difference between the Rating (1=low 6=high) in Least developed countries and Rating (1=low 6=high) in Nicaragua?
Offer a very short reply. -0.17. In the year 2011, what is the difference between the Rating (1=low 6=high) of Sub-Saharan Africa (all income levels) and Rating (1=low 6=high) of Lesotho?
Make the answer very short. -0.12. In the year 2011, what is the difference between the Rating (1=low 6=high) of Sub-Saharan Africa (all income levels) and Rating (1=low 6=high) of Nicaragua?
Provide a succinct answer. -0.12. In the year 2012, what is the difference between the Rating (1=low 6=high) of Least developed countries and Rating (1=low 6=high) of Sub-Saharan Africa (all income levels)?
Offer a very short reply. -0.06. In the year 2012, what is the difference between the Rating (1=low 6=high) in Least developed countries and Rating (1=low 6=high) in Lesotho?
Give a very brief answer. -0.22. In the year 2012, what is the difference between the Rating (1=low 6=high) of Least developed countries and Rating (1=low 6=high) of Nicaragua?
Your answer should be very brief. -0.22. In the year 2012, what is the difference between the Rating (1=low 6=high) of Sub-Saharan Africa (all income levels) and Rating (1=low 6=high) of Lesotho?
Your answer should be compact. -0.17. In the year 2012, what is the difference between the Rating (1=low 6=high) of Sub-Saharan Africa (all income levels) and Rating (1=low 6=high) of Nicaragua?
Offer a very short reply. -0.17. In the year 2012, what is the difference between the Rating (1=low 6=high) of Lesotho and Rating (1=low 6=high) of Nicaragua?
Give a very brief answer. 0. In the year 2013, what is the difference between the Rating (1=low 6=high) in Least developed countries and Rating (1=low 6=high) in Sub-Saharan Africa (all income levels)?
Ensure brevity in your answer.  -0.05. In the year 2013, what is the difference between the Rating (1=low 6=high) of Least developed countries and Rating (1=low 6=high) of Lesotho?
Offer a very short reply. -0.23. In the year 2013, what is the difference between the Rating (1=low 6=high) in Least developed countries and Rating (1=low 6=high) in Nicaragua?
Provide a succinct answer. -0.23. In the year 2013, what is the difference between the Rating (1=low 6=high) in Sub-Saharan Africa (all income levels) and Rating (1=low 6=high) in Lesotho?
Your answer should be compact. -0.18. In the year 2013, what is the difference between the Rating (1=low 6=high) of Sub-Saharan Africa (all income levels) and Rating (1=low 6=high) of Nicaragua?
Your answer should be very brief. -0.18. In the year 2014, what is the difference between the Rating (1=low 6=high) of Least developed countries and Rating (1=low 6=high) of Sub-Saharan Africa (all income levels)?
Provide a succinct answer. -0.01. In the year 2014, what is the difference between the Rating (1=low 6=high) of Least developed countries and Rating (1=low 6=high) of Lesotho?
Your answer should be very brief. -0.16. In the year 2014, what is the difference between the Rating (1=low 6=high) of Least developed countries and Rating (1=low 6=high) of Nicaragua?
Offer a terse response. -0.16. In the year 2014, what is the difference between the Rating (1=low 6=high) in Sub-Saharan Africa (all income levels) and Rating (1=low 6=high) in Lesotho?
Keep it short and to the point. -0.14. In the year 2014, what is the difference between the Rating (1=low 6=high) of Sub-Saharan Africa (all income levels) and Rating (1=low 6=high) of Nicaragua?
Offer a terse response. -0.14. What is the ratio of the Rating (1=low 6=high) of Sub-Saharan Africa (all income levels) in 2007 to that in 2008?
Provide a short and direct response. 1.01. What is the ratio of the Rating (1=low 6=high) of Lesotho in 2007 to that in 2008?
Your answer should be compact. 1. What is the ratio of the Rating (1=low 6=high) in Least developed countries in 2007 to that in 2009?
Give a very brief answer. 0.99. What is the ratio of the Rating (1=low 6=high) in Sub-Saharan Africa (all income levels) in 2007 to that in 2009?
Offer a terse response. 1. What is the ratio of the Rating (1=low 6=high) in Sub-Saharan Africa (all income levels) in 2007 to that in 2010?
Make the answer very short. 0.99. What is the ratio of the Rating (1=low 6=high) in Lesotho in 2007 to that in 2010?
Ensure brevity in your answer.  1. What is the ratio of the Rating (1=low 6=high) of Least developed countries in 2007 to that in 2011?
Your answer should be very brief. 1.01. What is the ratio of the Rating (1=low 6=high) of Sub-Saharan Africa (all income levels) in 2007 to that in 2011?
Make the answer very short. 1.01. What is the ratio of the Rating (1=low 6=high) of Lesotho in 2007 to that in 2011?
Make the answer very short. 1. What is the ratio of the Rating (1=low 6=high) in Nicaragua in 2007 to that in 2011?
Offer a very short reply. 1. What is the ratio of the Rating (1=low 6=high) of Least developed countries in 2007 to that in 2012?
Provide a succinct answer. 1.03. What is the ratio of the Rating (1=low 6=high) of Sub-Saharan Africa (all income levels) in 2007 to that in 2012?
Your response must be concise. 1.03. What is the ratio of the Rating (1=low 6=high) of Nicaragua in 2007 to that in 2012?
Offer a very short reply. 1. What is the ratio of the Rating (1=low 6=high) of Least developed countries in 2007 to that in 2013?
Your response must be concise. 1.03. What is the ratio of the Rating (1=low 6=high) in Sub-Saharan Africa (all income levels) in 2007 to that in 2013?
Your response must be concise. 1.03. What is the ratio of the Rating (1=low 6=high) of Sub-Saharan Africa (all income levels) in 2007 to that in 2014?
Provide a succinct answer. 1.02. What is the ratio of the Rating (1=low 6=high) in Lesotho in 2007 to that in 2014?
Your answer should be compact. 1. What is the ratio of the Rating (1=low 6=high) in Least developed countries in 2008 to that in 2009?
Give a very brief answer. 0.99. What is the ratio of the Rating (1=low 6=high) in Sub-Saharan Africa (all income levels) in 2008 to that in 2009?
Provide a succinct answer. 0.99. What is the ratio of the Rating (1=low 6=high) in Nicaragua in 2008 to that in 2009?
Offer a terse response. 1. What is the ratio of the Rating (1=low 6=high) in Least developed countries in 2008 to that in 2010?
Provide a succinct answer. 0.99. What is the ratio of the Rating (1=low 6=high) in Sub-Saharan Africa (all income levels) in 2008 to that in 2010?
Make the answer very short. 0.98. What is the ratio of the Rating (1=low 6=high) in Least developed countries in 2008 to that in 2012?
Provide a short and direct response. 1.02. What is the ratio of the Rating (1=low 6=high) of Sub-Saharan Africa (all income levels) in 2008 to that in 2012?
Offer a very short reply. 1.01. What is the ratio of the Rating (1=low 6=high) in Least developed countries in 2008 to that in 2013?
Give a very brief answer. 1.03. What is the ratio of the Rating (1=low 6=high) in Sub-Saharan Africa (all income levels) in 2008 to that in 2013?
Ensure brevity in your answer.  1.02. What is the ratio of the Rating (1=low 6=high) in Lesotho in 2008 to that in 2013?
Make the answer very short. 1. What is the ratio of the Rating (1=low 6=high) in Nicaragua in 2008 to that in 2013?
Offer a terse response. 1. What is the ratio of the Rating (1=low 6=high) of Nicaragua in 2008 to that in 2014?
Provide a succinct answer. 1. What is the ratio of the Rating (1=low 6=high) of Lesotho in 2009 to that in 2010?
Give a very brief answer. 1. What is the ratio of the Rating (1=low 6=high) of Nicaragua in 2009 to that in 2010?
Make the answer very short. 1. What is the ratio of the Rating (1=low 6=high) in Least developed countries in 2009 to that in 2011?
Give a very brief answer. 1.02. What is the ratio of the Rating (1=low 6=high) in Sub-Saharan Africa (all income levels) in 2009 to that in 2011?
Ensure brevity in your answer.  1.01. What is the ratio of the Rating (1=low 6=high) in Least developed countries in 2009 to that in 2012?
Offer a very short reply. 1.03. What is the ratio of the Rating (1=low 6=high) of Sub-Saharan Africa (all income levels) in 2009 to that in 2012?
Your response must be concise. 1.03. What is the ratio of the Rating (1=low 6=high) in Lesotho in 2009 to that in 2012?
Keep it short and to the point. 1. What is the ratio of the Rating (1=low 6=high) in Least developed countries in 2009 to that in 2013?
Ensure brevity in your answer.  1.04. What is the ratio of the Rating (1=low 6=high) of Sub-Saharan Africa (all income levels) in 2009 to that in 2013?
Make the answer very short. 1.03. What is the ratio of the Rating (1=low 6=high) of Least developed countries in 2009 to that in 2014?
Offer a terse response. 1.01. What is the ratio of the Rating (1=low 6=high) of Sub-Saharan Africa (all income levels) in 2009 to that in 2014?
Provide a short and direct response. 1.02. What is the ratio of the Rating (1=low 6=high) in Lesotho in 2009 to that in 2014?
Provide a short and direct response. 1. What is the ratio of the Rating (1=low 6=high) of Nicaragua in 2009 to that in 2014?
Make the answer very short. 1. What is the ratio of the Rating (1=low 6=high) of Least developed countries in 2010 to that in 2011?
Keep it short and to the point. 1.02. What is the ratio of the Rating (1=low 6=high) of Sub-Saharan Africa (all income levels) in 2010 to that in 2011?
Give a very brief answer. 1.01. What is the ratio of the Rating (1=low 6=high) of Lesotho in 2010 to that in 2011?
Make the answer very short. 1. What is the ratio of the Rating (1=low 6=high) of Nicaragua in 2010 to that in 2011?
Give a very brief answer. 1. What is the ratio of the Rating (1=low 6=high) in Least developed countries in 2010 to that in 2012?
Give a very brief answer. 1.03. What is the ratio of the Rating (1=low 6=high) of Sub-Saharan Africa (all income levels) in 2010 to that in 2012?
Offer a terse response. 1.03. What is the ratio of the Rating (1=low 6=high) of Lesotho in 2010 to that in 2012?
Make the answer very short. 1. What is the ratio of the Rating (1=low 6=high) of Least developed countries in 2010 to that in 2013?
Your answer should be compact. 1.04. What is the ratio of the Rating (1=low 6=high) of Sub-Saharan Africa (all income levels) in 2010 to that in 2013?
Offer a terse response. 1.04. What is the ratio of the Rating (1=low 6=high) of Lesotho in 2010 to that in 2013?
Give a very brief answer. 1. What is the ratio of the Rating (1=low 6=high) of Nicaragua in 2010 to that in 2013?
Keep it short and to the point. 1. What is the ratio of the Rating (1=low 6=high) of Least developed countries in 2010 to that in 2014?
Give a very brief answer. 1.01. What is the ratio of the Rating (1=low 6=high) in Sub-Saharan Africa (all income levels) in 2010 to that in 2014?
Your answer should be compact. 1.02. What is the ratio of the Rating (1=low 6=high) of Lesotho in 2010 to that in 2014?
Offer a very short reply. 1. What is the ratio of the Rating (1=low 6=high) in Least developed countries in 2011 to that in 2012?
Your answer should be very brief. 1.02. What is the ratio of the Rating (1=low 6=high) in Sub-Saharan Africa (all income levels) in 2011 to that in 2012?
Give a very brief answer. 1.02. What is the ratio of the Rating (1=low 6=high) of Least developed countries in 2011 to that in 2013?
Your answer should be compact. 1.02. What is the ratio of the Rating (1=low 6=high) in Sub-Saharan Africa (all income levels) in 2011 to that in 2013?
Give a very brief answer. 1.02. What is the ratio of the Rating (1=low 6=high) in Lesotho in 2011 to that in 2013?
Provide a succinct answer. 1. What is the ratio of the Rating (1=low 6=high) of Sub-Saharan Africa (all income levels) in 2011 to that in 2014?
Offer a terse response. 1.01. What is the ratio of the Rating (1=low 6=high) of Lesotho in 2011 to that in 2014?
Provide a short and direct response. 1. What is the ratio of the Rating (1=low 6=high) in Least developed countries in 2012 to that in 2013?
Give a very brief answer. 1. What is the ratio of the Rating (1=low 6=high) of Least developed countries in 2012 to that in 2014?
Make the answer very short. 0.98. What is the ratio of the Rating (1=low 6=high) of Sub-Saharan Africa (all income levels) in 2012 to that in 2014?
Give a very brief answer. 0.99. What is the ratio of the Rating (1=low 6=high) of Lesotho in 2012 to that in 2014?
Provide a succinct answer. 1. What is the ratio of the Rating (1=low 6=high) of Least developed countries in 2013 to that in 2014?
Offer a terse response. 0.97. What is the ratio of the Rating (1=low 6=high) in Lesotho in 2013 to that in 2014?
Provide a short and direct response. 1. What is the ratio of the Rating (1=low 6=high) in Nicaragua in 2013 to that in 2014?
Ensure brevity in your answer.  1. What is the difference between the highest and the second highest Rating (1=low 6=high) of Sub-Saharan Africa (all income levels)?
Make the answer very short. 0.01. What is the difference between the highest and the second highest Rating (1=low 6=high) in Lesotho?
Keep it short and to the point. 0. What is the difference between the highest and the second highest Rating (1=low 6=high) of Nicaragua?
Ensure brevity in your answer.  0. What is the difference between the highest and the lowest Rating (1=low 6=high) of Least developed countries?
Provide a succinct answer. 0.1. What is the difference between the highest and the lowest Rating (1=low 6=high) in Sub-Saharan Africa (all income levels)?
Your answer should be very brief. 0.1. What is the difference between the highest and the lowest Rating (1=low 6=high) in Lesotho?
Provide a succinct answer. 0. What is the difference between the highest and the lowest Rating (1=low 6=high) of Nicaragua?
Offer a very short reply. 0. 